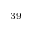Convert formula to latex. <formula><loc_0><loc_0><loc_500><loc_500>^ { 3 9 }</formula> 